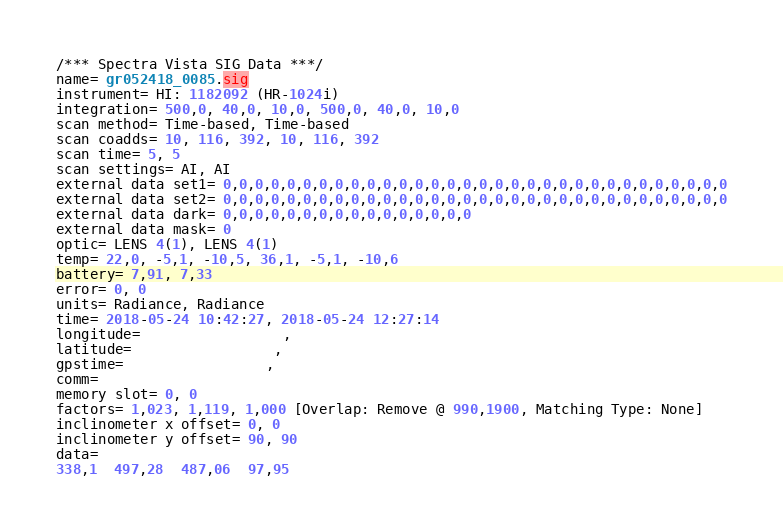<code> <loc_0><loc_0><loc_500><loc_500><_SML_>/*** Spectra Vista SIG Data ***/
name= gr052418_0085.sig
instrument= HI: 1182092 (HR-1024i)
integration= 500,0, 40,0, 10,0, 500,0, 40,0, 10,0
scan method= Time-based, Time-based
scan coadds= 10, 116, 392, 10, 116, 392
scan time= 5, 5
scan settings= AI, AI
external data set1= 0,0,0,0,0,0,0,0,0,0,0,0,0,0,0,0,0,0,0,0,0,0,0,0,0,0,0,0,0,0,0,0
external data set2= 0,0,0,0,0,0,0,0,0,0,0,0,0,0,0,0,0,0,0,0,0,0,0,0,0,0,0,0,0,0,0,0
external data dark= 0,0,0,0,0,0,0,0,0,0,0,0,0,0,0,0
external data mask= 0
optic= LENS 4(1), LENS 4(1)
temp= 22,0, -5,1, -10,5, 36,1, -5,1, -10,6
battery= 7,91, 7,33
error= 0, 0
units= Radiance, Radiance
time= 2018-05-24 10:42:27, 2018-05-24 12:27:14
longitude=                 ,                 
latitude=                 ,                 
gpstime=                 ,                 
comm= 
memory slot= 0, 0
factors= 1,023, 1,119, 1,000 [Overlap: Remove @ 990,1900, Matching Type: None]
inclinometer x offset= 0, 0
inclinometer y offset= 90, 90
data= 
338,1  497,28  487,06  97,95</code> 